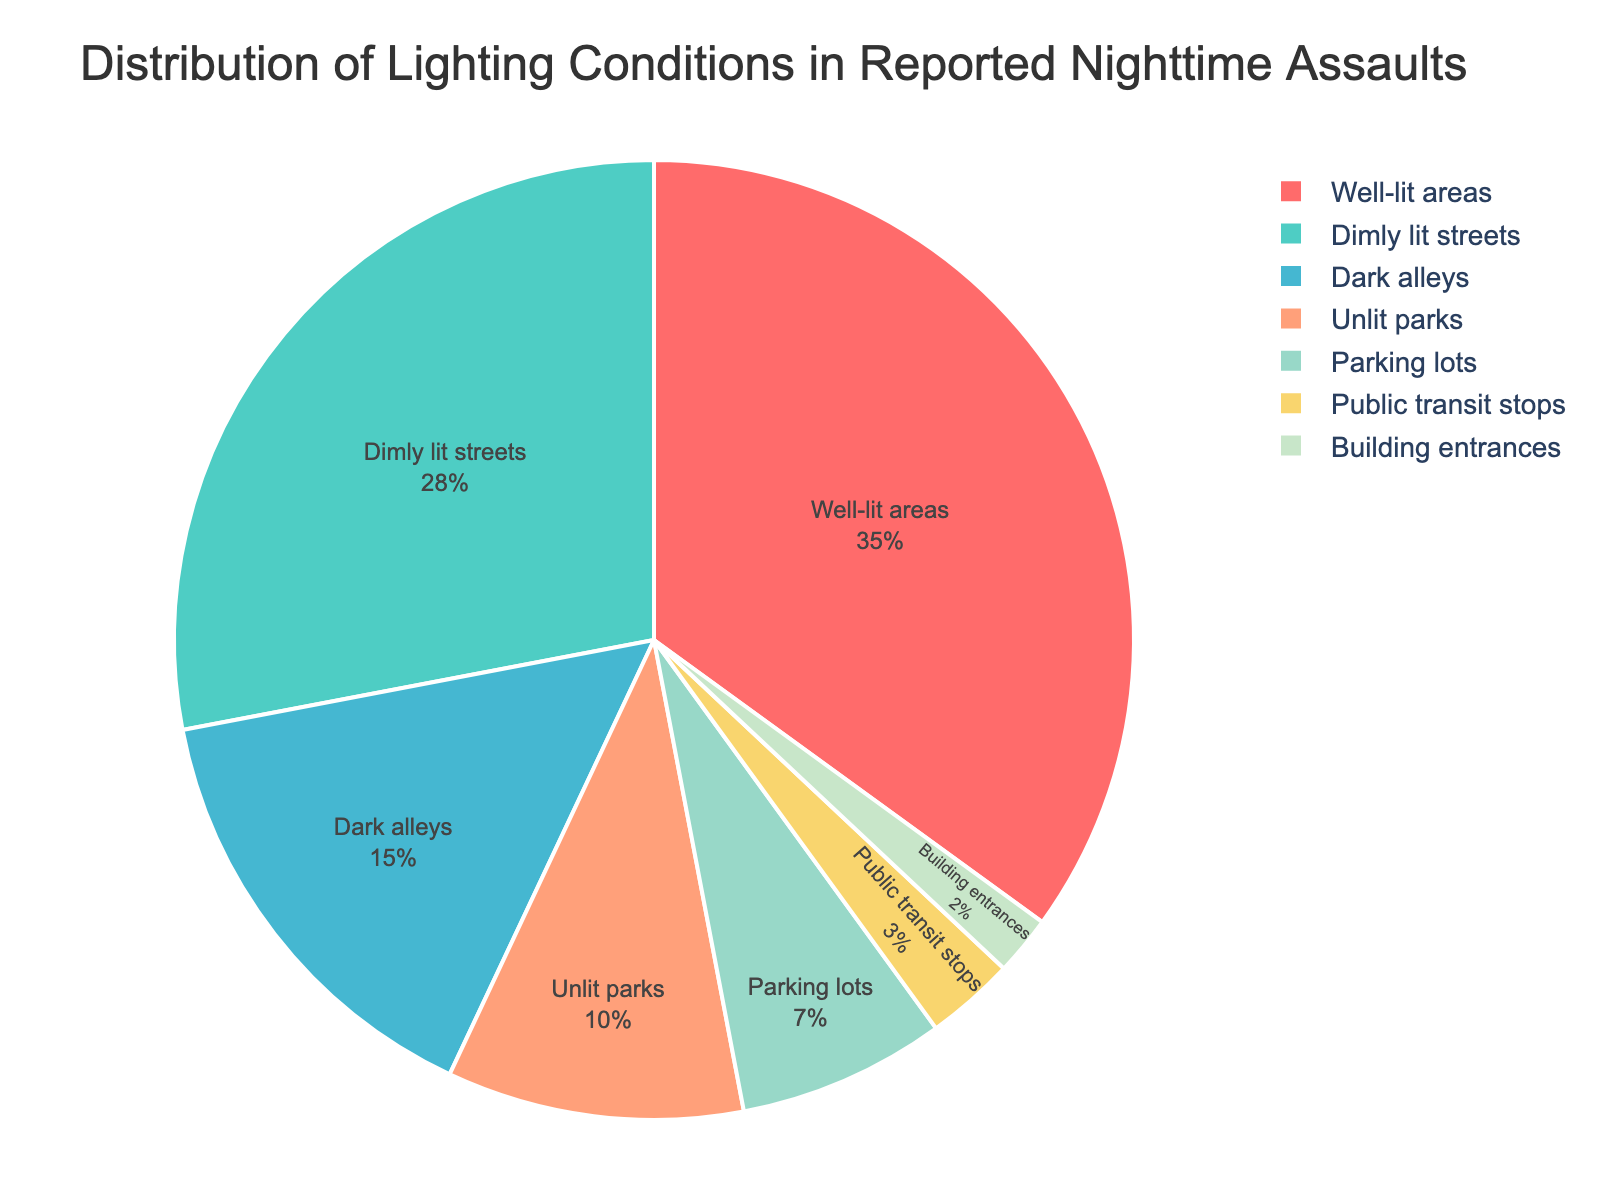What's the category with the highest percentage of reported nighttime assaults? The pie chart shows different lighting conditions with respective percentages. By observing, 'Well-lit areas' has the largest slice with 35%.
Answer: Well-lit areas What is the combined percentage of assaults occurring in 'Dark alleys' and 'Unlit parks'? According to the chart, 'Dark alleys' account for 15% and 'Unlit parks' account for 10%. Summing these values gives 15% + 10% = 25%.
Answer: 25% Which lighting condition has a smaller percentage of assaults than 'Dimly lit streets' but more than 'Public transit stops'? From the chart, 'Dimly lit streets' is 28%, and 'Public transit stops' is 3%. The category that falls between these percentages is 'Dark alleys' with 15%.
Answer: Dark alleys By how much is the percentage of assaults in 'Parking lots' higher than in 'Public transit stops'? 'Parking lots' show 7% while 'Public transit stops' show 3%. Subtracting these gives 7% - 3% = 4%.
Answer: 4% What is the visual characteristic (color) of the category with the lowest percentage? The chart uses different colors for each category, and 'Building entrances' with 2% has a light green color.
Answer: Light green What is the total percentage of assaults occurring in areas that are either 'Dimly lit streets' or 'Well-lit areas'? 'Well-lit areas' is 35% and 'Dimly lit streets' is 28%. Summing these gives 35% + 28% = 63%.
Answer: 63% Which category shows the second smallest percentage of assaults? By observing the chart, 'Public transit stops' have a percentage of 3%, which is the second smallest after 'Building entrances' with 2%.
Answer: Public transit stops How much higher is the percentage of assaults in 'Well-lit areas' compared to 'Dark alleys'? 'Well-lit areas' have 35% assaults and 'Dark alleys' have 15%. Subtracting these gives 35% - 15% = 20%.
Answer: 20% If you combined 'Parking lots' and 'Building entrances', what percentage of assaults would be represented? Summing up the percentages: 'Parking lots' with 7% and 'Building entrances' with 2% gives 7% + 2% = 9%.
Answer: 9% Which category has the closest percentage to 'Unlit parks'? 'Unlit parks' have a percentage of 10%. The closest percentage to this is 'Parking lots' with 7%.
Answer: Parking lots 